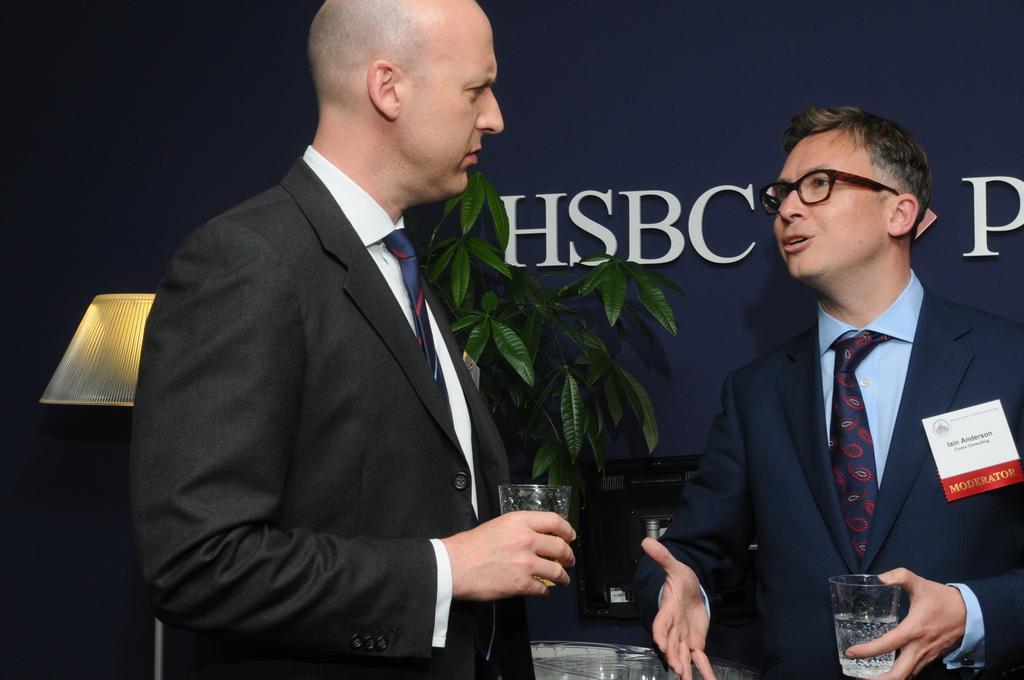Can you describe this image briefly? In this image we can see men standing and holding glass tumblers in their hands. In the background there are advertisement, desktop, houseplant and a table lamp. 